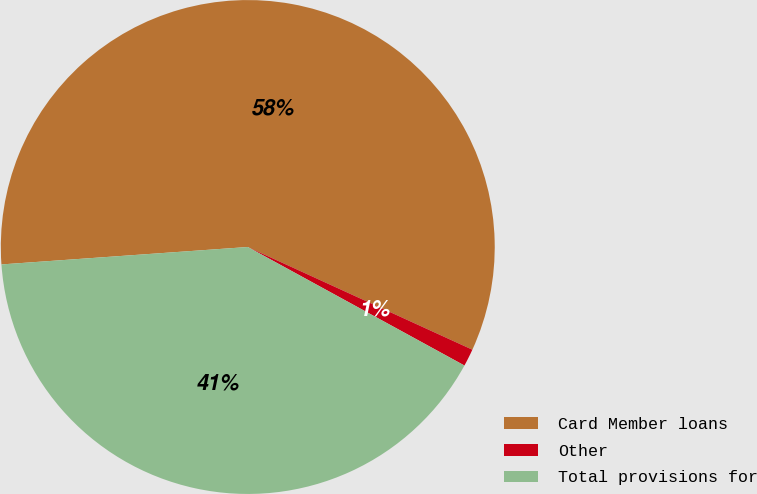<chart> <loc_0><loc_0><loc_500><loc_500><pie_chart><fcel>Card Member loans<fcel>Other<fcel>Total provisions for<nl><fcel>57.95%<fcel>1.14%<fcel>40.91%<nl></chart> 